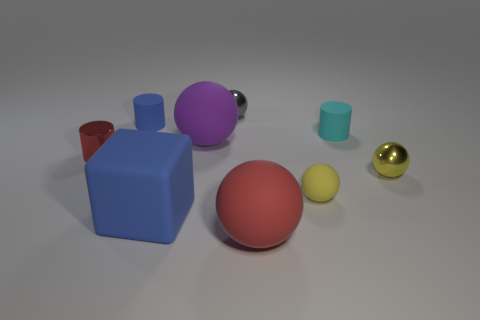What material is the tiny thing that is the same color as the large rubber block?
Provide a short and direct response. Rubber. Is the material of the big red sphere the same as the cyan cylinder?
Your answer should be very brief. Yes. How many cylinders have the same material as the large red ball?
Make the answer very short. 2. What is the color of the tiny cylinder that is made of the same material as the small gray thing?
Your answer should be very brief. Red. There is a yellow rubber object; what shape is it?
Ensure brevity in your answer.  Sphere. There is a large object that is right of the tiny gray ball; what material is it?
Make the answer very short. Rubber. Is there a metal ball of the same color as the shiny cylinder?
Provide a short and direct response. No. There is a gray metallic thing that is the same size as the yellow metal object; what is its shape?
Your answer should be very brief. Sphere. The tiny matte object to the right of the tiny yellow rubber object is what color?
Provide a succinct answer. Cyan. Are there any big blue cubes that are in front of the red thing that is behind the red matte ball?
Offer a terse response. Yes. 